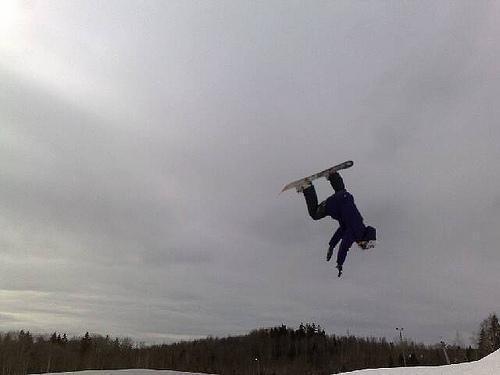How many cups in the image are black?
Give a very brief answer. 0. 